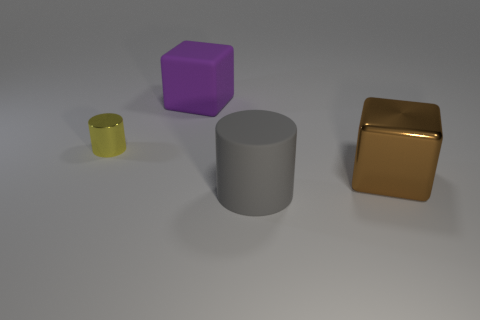What is the material of the other gray object that is the same shape as the small metallic object?
Ensure brevity in your answer.  Rubber. Is the shape of the big object that is behind the yellow shiny cylinder the same as the yellow shiny object that is behind the big metal cube?
Provide a short and direct response. No. How many objects are rubber things or shiny things that are on the right side of the tiny thing?
Provide a short and direct response. 3. How many yellow cylinders have the same size as the gray rubber cylinder?
Provide a short and direct response. 0. What number of purple things are rubber cylinders or tiny things?
Provide a short and direct response. 0. The metallic object that is behind the large thing to the right of the gray cylinder is what shape?
Your response must be concise. Cylinder. There is a gray object that is the same size as the brown shiny object; what is its shape?
Give a very brief answer. Cylinder. Are there any tiny metallic cylinders that have the same color as the small metal object?
Your answer should be compact. No. Are there an equal number of purple rubber things that are in front of the small yellow object and brown metal objects that are on the right side of the brown metal cube?
Your answer should be very brief. Yes. Do the brown metallic object and the small object that is behind the gray rubber cylinder have the same shape?
Keep it short and to the point. No. 